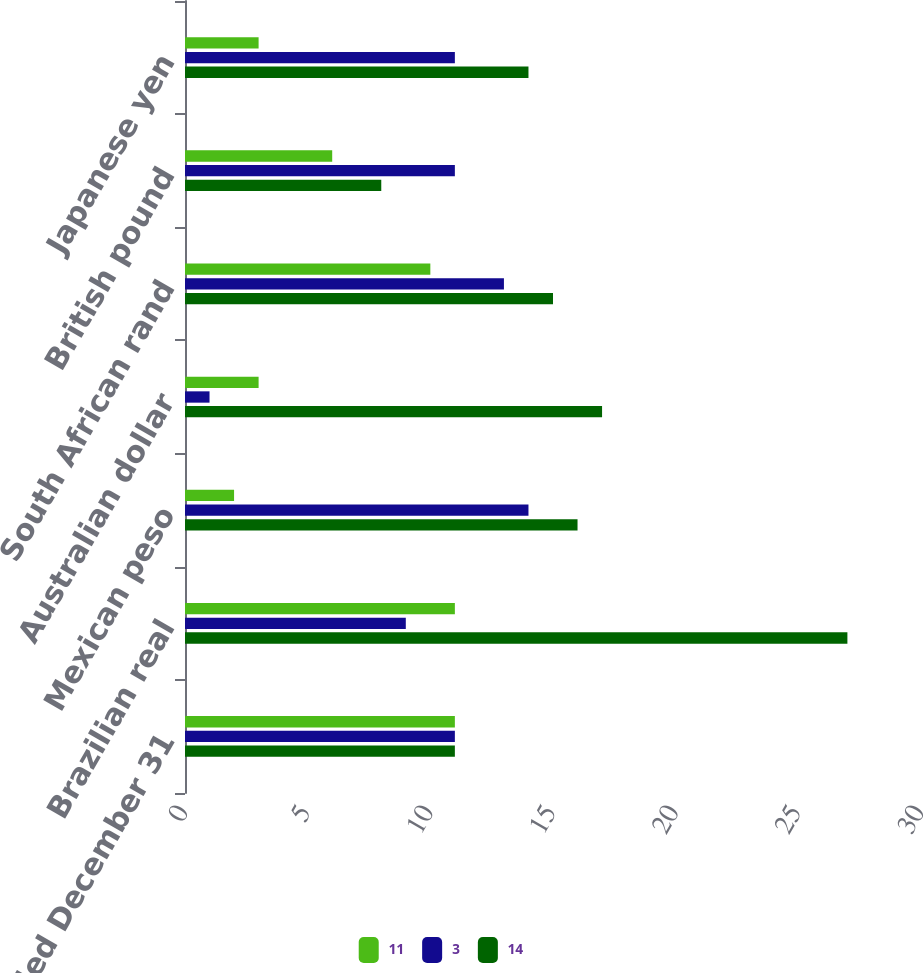Convert chart. <chart><loc_0><loc_0><loc_500><loc_500><stacked_bar_chart><ecel><fcel>Year Ended December 31<fcel>Brazilian real<fcel>Mexican peso<fcel>Australian dollar<fcel>South African rand<fcel>British pound<fcel>Japanese yen<nl><fcel>11<fcel>11<fcel>11<fcel>2<fcel>3<fcel>10<fcel>6<fcel>3<nl><fcel>3<fcel>11<fcel>9<fcel>14<fcel>1<fcel>13<fcel>11<fcel>11<nl><fcel>14<fcel>11<fcel>27<fcel>16<fcel>17<fcel>15<fcel>8<fcel>14<nl></chart> 